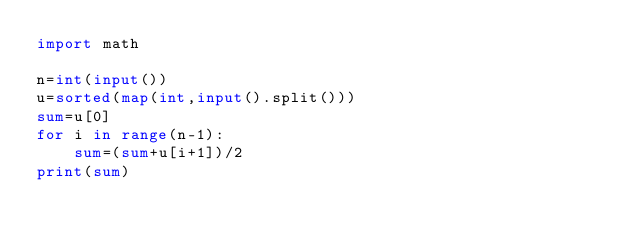Convert code to text. <code><loc_0><loc_0><loc_500><loc_500><_Python_>import math

n=int(input())
u=sorted(map(int,input().split()))
sum=u[0]
for i in range(n-1):
    sum=(sum+u[i+1])/2
print(sum)
</code> 